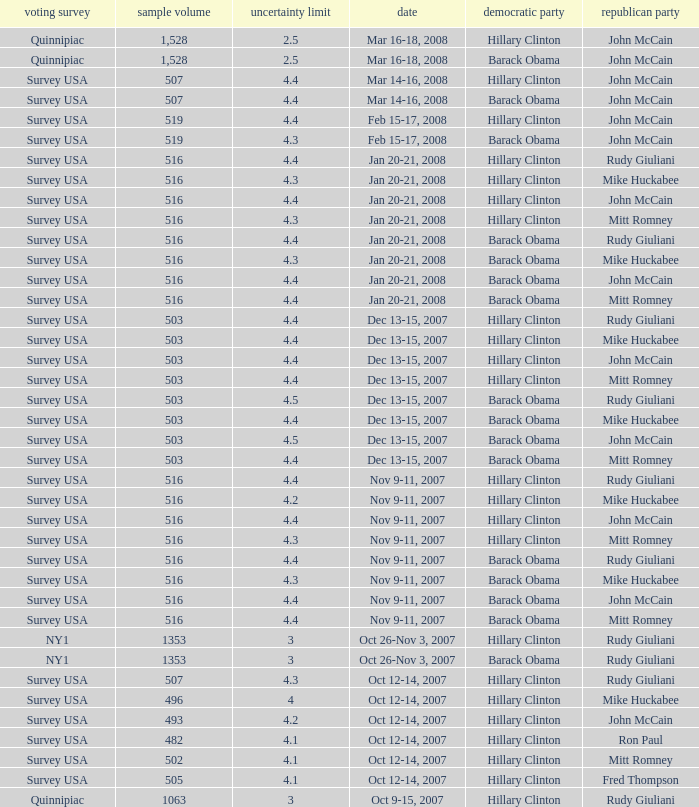Which Democrat was selected in the poll with a sample size smaller than 516 where the Republican chosen was Ron Paul? Hillary Clinton. 